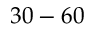<formula> <loc_0><loc_0><loc_500><loc_500>3 0 - 6 0</formula> 